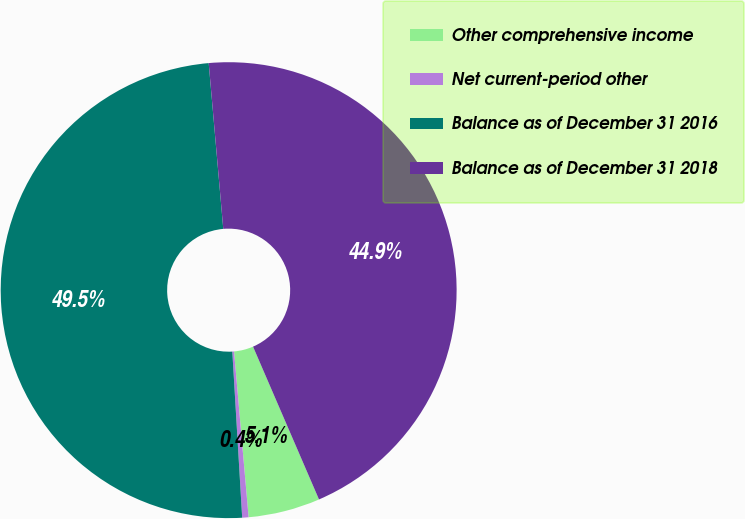Convert chart. <chart><loc_0><loc_0><loc_500><loc_500><pie_chart><fcel>Other comprehensive income<fcel>Net current-period other<fcel>Balance as of December 31 2016<fcel>Balance as of December 31 2018<nl><fcel>5.09%<fcel>0.45%<fcel>49.55%<fcel>44.91%<nl></chart> 